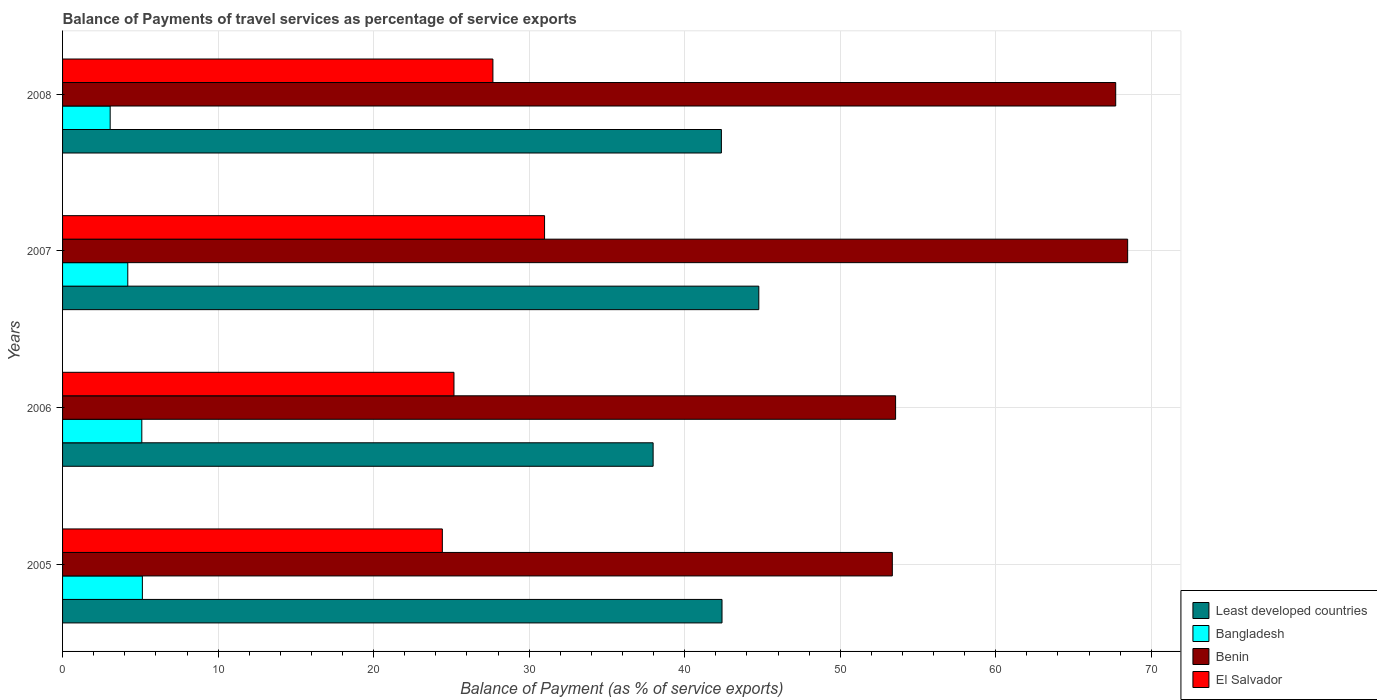How many groups of bars are there?
Ensure brevity in your answer.  4. Are the number of bars on each tick of the Y-axis equal?
Offer a very short reply. Yes. How many bars are there on the 4th tick from the top?
Ensure brevity in your answer.  4. What is the balance of payments of travel services in Benin in 2005?
Provide a succinct answer. 53.35. Across all years, what is the maximum balance of payments of travel services in Bangladesh?
Offer a very short reply. 5.13. Across all years, what is the minimum balance of payments of travel services in Bangladesh?
Offer a very short reply. 3.06. In which year was the balance of payments of travel services in Benin minimum?
Offer a terse response. 2005. What is the total balance of payments of travel services in Bangladesh in the graph?
Give a very brief answer. 17.48. What is the difference between the balance of payments of travel services in Benin in 2006 and that in 2007?
Ensure brevity in your answer.  -14.92. What is the difference between the balance of payments of travel services in Bangladesh in 2005 and the balance of payments of travel services in El Salvador in 2008?
Offer a terse response. -22.54. What is the average balance of payments of travel services in Bangladesh per year?
Ensure brevity in your answer.  4.37. In the year 2007, what is the difference between the balance of payments of travel services in Benin and balance of payments of travel services in Least developed countries?
Offer a terse response. 23.71. What is the ratio of the balance of payments of travel services in Benin in 2005 to that in 2007?
Keep it short and to the point. 0.78. Is the balance of payments of travel services in El Salvador in 2006 less than that in 2008?
Give a very brief answer. Yes. Is the difference between the balance of payments of travel services in Benin in 2005 and 2007 greater than the difference between the balance of payments of travel services in Least developed countries in 2005 and 2007?
Ensure brevity in your answer.  No. What is the difference between the highest and the second highest balance of payments of travel services in Bangladesh?
Your answer should be compact. 0.04. What is the difference between the highest and the lowest balance of payments of travel services in Benin?
Make the answer very short. 15.13. Is it the case that in every year, the sum of the balance of payments of travel services in Benin and balance of payments of travel services in Least developed countries is greater than the sum of balance of payments of travel services in El Salvador and balance of payments of travel services in Bangladesh?
Offer a very short reply. Yes. What does the 3rd bar from the top in 2008 represents?
Your response must be concise. Bangladesh. What does the 4th bar from the bottom in 2008 represents?
Offer a very short reply. El Salvador. Is it the case that in every year, the sum of the balance of payments of travel services in El Salvador and balance of payments of travel services in Bangladesh is greater than the balance of payments of travel services in Least developed countries?
Keep it short and to the point. No. How many bars are there?
Keep it short and to the point. 16. Are all the bars in the graph horizontal?
Your response must be concise. Yes. Are the values on the major ticks of X-axis written in scientific E-notation?
Your answer should be compact. No. Does the graph contain grids?
Keep it short and to the point. Yes. Where does the legend appear in the graph?
Provide a short and direct response. Bottom right. How many legend labels are there?
Ensure brevity in your answer.  4. How are the legend labels stacked?
Give a very brief answer. Vertical. What is the title of the graph?
Provide a succinct answer. Balance of Payments of travel services as percentage of service exports. Does "Bahamas" appear as one of the legend labels in the graph?
Your response must be concise. No. What is the label or title of the X-axis?
Keep it short and to the point. Balance of Payment (as % of service exports). What is the label or title of the Y-axis?
Offer a very short reply. Years. What is the Balance of Payment (as % of service exports) in Least developed countries in 2005?
Offer a very short reply. 42.4. What is the Balance of Payment (as % of service exports) of Bangladesh in 2005?
Make the answer very short. 5.13. What is the Balance of Payment (as % of service exports) of Benin in 2005?
Ensure brevity in your answer.  53.35. What is the Balance of Payment (as % of service exports) of El Salvador in 2005?
Ensure brevity in your answer.  24.42. What is the Balance of Payment (as % of service exports) of Least developed countries in 2006?
Give a very brief answer. 37.97. What is the Balance of Payment (as % of service exports) in Bangladesh in 2006?
Your response must be concise. 5.1. What is the Balance of Payment (as % of service exports) in Benin in 2006?
Offer a terse response. 53.56. What is the Balance of Payment (as % of service exports) of El Salvador in 2006?
Offer a terse response. 25.17. What is the Balance of Payment (as % of service exports) of Least developed countries in 2007?
Give a very brief answer. 44.76. What is the Balance of Payment (as % of service exports) in Bangladesh in 2007?
Offer a terse response. 4.19. What is the Balance of Payment (as % of service exports) of Benin in 2007?
Offer a very short reply. 68.48. What is the Balance of Payment (as % of service exports) of El Salvador in 2007?
Give a very brief answer. 30.99. What is the Balance of Payment (as % of service exports) in Least developed countries in 2008?
Provide a short and direct response. 42.36. What is the Balance of Payment (as % of service exports) in Bangladesh in 2008?
Your answer should be compact. 3.06. What is the Balance of Payment (as % of service exports) in Benin in 2008?
Keep it short and to the point. 67.71. What is the Balance of Payment (as % of service exports) in El Salvador in 2008?
Your answer should be very brief. 27.67. Across all years, what is the maximum Balance of Payment (as % of service exports) of Least developed countries?
Your answer should be very brief. 44.76. Across all years, what is the maximum Balance of Payment (as % of service exports) in Bangladesh?
Keep it short and to the point. 5.13. Across all years, what is the maximum Balance of Payment (as % of service exports) in Benin?
Provide a short and direct response. 68.48. Across all years, what is the maximum Balance of Payment (as % of service exports) of El Salvador?
Provide a succinct answer. 30.99. Across all years, what is the minimum Balance of Payment (as % of service exports) of Least developed countries?
Your response must be concise. 37.97. Across all years, what is the minimum Balance of Payment (as % of service exports) in Bangladesh?
Your answer should be compact. 3.06. Across all years, what is the minimum Balance of Payment (as % of service exports) in Benin?
Your answer should be compact. 53.35. Across all years, what is the minimum Balance of Payment (as % of service exports) of El Salvador?
Make the answer very short. 24.42. What is the total Balance of Payment (as % of service exports) of Least developed countries in the graph?
Give a very brief answer. 167.49. What is the total Balance of Payment (as % of service exports) of Bangladesh in the graph?
Give a very brief answer. 17.48. What is the total Balance of Payment (as % of service exports) of Benin in the graph?
Ensure brevity in your answer.  243.1. What is the total Balance of Payment (as % of service exports) in El Salvador in the graph?
Make the answer very short. 108.24. What is the difference between the Balance of Payment (as % of service exports) in Least developed countries in 2005 and that in 2006?
Your answer should be compact. 4.43. What is the difference between the Balance of Payment (as % of service exports) in Bangladesh in 2005 and that in 2006?
Your response must be concise. 0.04. What is the difference between the Balance of Payment (as % of service exports) of Benin in 2005 and that in 2006?
Offer a terse response. -0.21. What is the difference between the Balance of Payment (as % of service exports) in El Salvador in 2005 and that in 2006?
Provide a short and direct response. -0.75. What is the difference between the Balance of Payment (as % of service exports) of Least developed countries in 2005 and that in 2007?
Ensure brevity in your answer.  -2.37. What is the difference between the Balance of Payment (as % of service exports) of Bangladesh in 2005 and that in 2007?
Provide a succinct answer. 0.94. What is the difference between the Balance of Payment (as % of service exports) in Benin in 2005 and that in 2007?
Provide a short and direct response. -15.13. What is the difference between the Balance of Payment (as % of service exports) of El Salvador in 2005 and that in 2007?
Offer a terse response. -6.57. What is the difference between the Balance of Payment (as % of service exports) of Least developed countries in 2005 and that in 2008?
Your answer should be very brief. 0.04. What is the difference between the Balance of Payment (as % of service exports) in Bangladesh in 2005 and that in 2008?
Make the answer very short. 2.07. What is the difference between the Balance of Payment (as % of service exports) of Benin in 2005 and that in 2008?
Make the answer very short. -14.36. What is the difference between the Balance of Payment (as % of service exports) in El Salvador in 2005 and that in 2008?
Your response must be concise. -3.25. What is the difference between the Balance of Payment (as % of service exports) of Least developed countries in 2006 and that in 2007?
Your answer should be very brief. -6.79. What is the difference between the Balance of Payment (as % of service exports) in Bangladesh in 2006 and that in 2007?
Your answer should be very brief. 0.9. What is the difference between the Balance of Payment (as % of service exports) of Benin in 2006 and that in 2007?
Your answer should be very brief. -14.92. What is the difference between the Balance of Payment (as % of service exports) of El Salvador in 2006 and that in 2007?
Your answer should be very brief. -5.82. What is the difference between the Balance of Payment (as % of service exports) in Least developed countries in 2006 and that in 2008?
Provide a short and direct response. -4.39. What is the difference between the Balance of Payment (as % of service exports) of Bangladesh in 2006 and that in 2008?
Your answer should be very brief. 2.04. What is the difference between the Balance of Payment (as % of service exports) of Benin in 2006 and that in 2008?
Provide a short and direct response. -14.15. What is the difference between the Balance of Payment (as % of service exports) in El Salvador in 2006 and that in 2008?
Make the answer very short. -2.5. What is the difference between the Balance of Payment (as % of service exports) of Least developed countries in 2007 and that in 2008?
Your answer should be very brief. 2.41. What is the difference between the Balance of Payment (as % of service exports) of Bangladesh in 2007 and that in 2008?
Give a very brief answer. 1.13. What is the difference between the Balance of Payment (as % of service exports) in Benin in 2007 and that in 2008?
Keep it short and to the point. 0.77. What is the difference between the Balance of Payment (as % of service exports) in El Salvador in 2007 and that in 2008?
Your response must be concise. 3.32. What is the difference between the Balance of Payment (as % of service exports) in Least developed countries in 2005 and the Balance of Payment (as % of service exports) in Bangladesh in 2006?
Provide a short and direct response. 37.3. What is the difference between the Balance of Payment (as % of service exports) of Least developed countries in 2005 and the Balance of Payment (as % of service exports) of Benin in 2006?
Keep it short and to the point. -11.16. What is the difference between the Balance of Payment (as % of service exports) of Least developed countries in 2005 and the Balance of Payment (as % of service exports) of El Salvador in 2006?
Provide a succinct answer. 17.23. What is the difference between the Balance of Payment (as % of service exports) in Bangladesh in 2005 and the Balance of Payment (as % of service exports) in Benin in 2006?
Provide a short and direct response. -48.43. What is the difference between the Balance of Payment (as % of service exports) of Bangladesh in 2005 and the Balance of Payment (as % of service exports) of El Salvador in 2006?
Keep it short and to the point. -20.03. What is the difference between the Balance of Payment (as % of service exports) in Benin in 2005 and the Balance of Payment (as % of service exports) in El Salvador in 2006?
Offer a terse response. 28.18. What is the difference between the Balance of Payment (as % of service exports) of Least developed countries in 2005 and the Balance of Payment (as % of service exports) of Bangladesh in 2007?
Provide a succinct answer. 38.21. What is the difference between the Balance of Payment (as % of service exports) in Least developed countries in 2005 and the Balance of Payment (as % of service exports) in Benin in 2007?
Make the answer very short. -26.08. What is the difference between the Balance of Payment (as % of service exports) in Least developed countries in 2005 and the Balance of Payment (as % of service exports) in El Salvador in 2007?
Make the answer very short. 11.41. What is the difference between the Balance of Payment (as % of service exports) of Bangladesh in 2005 and the Balance of Payment (as % of service exports) of Benin in 2007?
Make the answer very short. -63.35. What is the difference between the Balance of Payment (as % of service exports) in Bangladesh in 2005 and the Balance of Payment (as % of service exports) in El Salvador in 2007?
Provide a short and direct response. -25.86. What is the difference between the Balance of Payment (as % of service exports) of Benin in 2005 and the Balance of Payment (as % of service exports) of El Salvador in 2007?
Your answer should be very brief. 22.36. What is the difference between the Balance of Payment (as % of service exports) of Least developed countries in 2005 and the Balance of Payment (as % of service exports) of Bangladesh in 2008?
Make the answer very short. 39.34. What is the difference between the Balance of Payment (as % of service exports) of Least developed countries in 2005 and the Balance of Payment (as % of service exports) of Benin in 2008?
Ensure brevity in your answer.  -25.31. What is the difference between the Balance of Payment (as % of service exports) in Least developed countries in 2005 and the Balance of Payment (as % of service exports) in El Salvador in 2008?
Give a very brief answer. 14.73. What is the difference between the Balance of Payment (as % of service exports) of Bangladesh in 2005 and the Balance of Payment (as % of service exports) of Benin in 2008?
Your answer should be compact. -62.58. What is the difference between the Balance of Payment (as % of service exports) in Bangladesh in 2005 and the Balance of Payment (as % of service exports) in El Salvador in 2008?
Keep it short and to the point. -22.54. What is the difference between the Balance of Payment (as % of service exports) in Benin in 2005 and the Balance of Payment (as % of service exports) in El Salvador in 2008?
Provide a succinct answer. 25.68. What is the difference between the Balance of Payment (as % of service exports) in Least developed countries in 2006 and the Balance of Payment (as % of service exports) in Bangladesh in 2007?
Give a very brief answer. 33.78. What is the difference between the Balance of Payment (as % of service exports) of Least developed countries in 2006 and the Balance of Payment (as % of service exports) of Benin in 2007?
Offer a very short reply. -30.51. What is the difference between the Balance of Payment (as % of service exports) in Least developed countries in 2006 and the Balance of Payment (as % of service exports) in El Salvador in 2007?
Your answer should be very brief. 6.98. What is the difference between the Balance of Payment (as % of service exports) in Bangladesh in 2006 and the Balance of Payment (as % of service exports) in Benin in 2007?
Make the answer very short. -63.38. What is the difference between the Balance of Payment (as % of service exports) of Bangladesh in 2006 and the Balance of Payment (as % of service exports) of El Salvador in 2007?
Your response must be concise. -25.89. What is the difference between the Balance of Payment (as % of service exports) of Benin in 2006 and the Balance of Payment (as % of service exports) of El Salvador in 2007?
Make the answer very short. 22.57. What is the difference between the Balance of Payment (as % of service exports) of Least developed countries in 2006 and the Balance of Payment (as % of service exports) of Bangladesh in 2008?
Give a very brief answer. 34.91. What is the difference between the Balance of Payment (as % of service exports) in Least developed countries in 2006 and the Balance of Payment (as % of service exports) in Benin in 2008?
Provide a succinct answer. -29.74. What is the difference between the Balance of Payment (as % of service exports) in Least developed countries in 2006 and the Balance of Payment (as % of service exports) in El Salvador in 2008?
Provide a short and direct response. 10.3. What is the difference between the Balance of Payment (as % of service exports) of Bangladesh in 2006 and the Balance of Payment (as % of service exports) of Benin in 2008?
Provide a short and direct response. -62.62. What is the difference between the Balance of Payment (as % of service exports) of Bangladesh in 2006 and the Balance of Payment (as % of service exports) of El Salvador in 2008?
Make the answer very short. -22.57. What is the difference between the Balance of Payment (as % of service exports) in Benin in 2006 and the Balance of Payment (as % of service exports) in El Salvador in 2008?
Provide a succinct answer. 25.89. What is the difference between the Balance of Payment (as % of service exports) in Least developed countries in 2007 and the Balance of Payment (as % of service exports) in Bangladesh in 2008?
Give a very brief answer. 41.7. What is the difference between the Balance of Payment (as % of service exports) of Least developed countries in 2007 and the Balance of Payment (as % of service exports) of Benin in 2008?
Provide a short and direct response. -22.95. What is the difference between the Balance of Payment (as % of service exports) of Least developed countries in 2007 and the Balance of Payment (as % of service exports) of El Salvador in 2008?
Give a very brief answer. 17.1. What is the difference between the Balance of Payment (as % of service exports) of Bangladesh in 2007 and the Balance of Payment (as % of service exports) of Benin in 2008?
Your answer should be compact. -63.52. What is the difference between the Balance of Payment (as % of service exports) in Bangladesh in 2007 and the Balance of Payment (as % of service exports) in El Salvador in 2008?
Ensure brevity in your answer.  -23.48. What is the difference between the Balance of Payment (as % of service exports) in Benin in 2007 and the Balance of Payment (as % of service exports) in El Salvador in 2008?
Your answer should be compact. 40.81. What is the average Balance of Payment (as % of service exports) in Least developed countries per year?
Give a very brief answer. 41.87. What is the average Balance of Payment (as % of service exports) of Bangladesh per year?
Your answer should be very brief. 4.37. What is the average Balance of Payment (as % of service exports) of Benin per year?
Your response must be concise. 60.77. What is the average Balance of Payment (as % of service exports) of El Salvador per year?
Provide a succinct answer. 27.06. In the year 2005, what is the difference between the Balance of Payment (as % of service exports) of Least developed countries and Balance of Payment (as % of service exports) of Bangladesh?
Provide a short and direct response. 37.27. In the year 2005, what is the difference between the Balance of Payment (as % of service exports) of Least developed countries and Balance of Payment (as % of service exports) of Benin?
Ensure brevity in your answer.  -10.95. In the year 2005, what is the difference between the Balance of Payment (as % of service exports) in Least developed countries and Balance of Payment (as % of service exports) in El Salvador?
Offer a terse response. 17.98. In the year 2005, what is the difference between the Balance of Payment (as % of service exports) in Bangladesh and Balance of Payment (as % of service exports) in Benin?
Offer a terse response. -48.22. In the year 2005, what is the difference between the Balance of Payment (as % of service exports) in Bangladesh and Balance of Payment (as % of service exports) in El Salvador?
Offer a terse response. -19.29. In the year 2005, what is the difference between the Balance of Payment (as % of service exports) of Benin and Balance of Payment (as % of service exports) of El Salvador?
Ensure brevity in your answer.  28.93. In the year 2006, what is the difference between the Balance of Payment (as % of service exports) in Least developed countries and Balance of Payment (as % of service exports) in Bangladesh?
Provide a succinct answer. 32.87. In the year 2006, what is the difference between the Balance of Payment (as % of service exports) in Least developed countries and Balance of Payment (as % of service exports) in Benin?
Your response must be concise. -15.59. In the year 2006, what is the difference between the Balance of Payment (as % of service exports) in Least developed countries and Balance of Payment (as % of service exports) in El Salvador?
Your response must be concise. 12.8. In the year 2006, what is the difference between the Balance of Payment (as % of service exports) of Bangladesh and Balance of Payment (as % of service exports) of Benin?
Provide a succinct answer. -48.46. In the year 2006, what is the difference between the Balance of Payment (as % of service exports) of Bangladesh and Balance of Payment (as % of service exports) of El Salvador?
Make the answer very short. -20.07. In the year 2006, what is the difference between the Balance of Payment (as % of service exports) of Benin and Balance of Payment (as % of service exports) of El Salvador?
Keep it short and to the point. 28.39. In the year 2007, what is the difference between the Balance of Payment (as % of service exports) of Least developed countries and Balance of Payment (as % of service exports) of Bangladesh?
Make the answer very short. 40.57. In the year 2007, what is the difference between the Balance of Payment (as % of service exports) of Least developed countries and Balance of Payment (as % of service exports) of Benin?
Keep it short and to the point. -23.71. In the year 2007, what is the difference between the Balance of Payment (as % of service exports) in Least developed countries and Balance of Payment (as % of service exports) in El Salvador?
Ensure brevity in your answer.  13.77. In the year 2007, what is the difference between the Balance of Payment (as % of service exports) of Bangladesh and Balance of Payment (as % of service exports) of Benin?
Provide a short and direct response. -64.29. In the year 2007, what is the difference between the Balance of Payment (as % of service exports) of Bangladesh and Balance of Payment (as % of service exports) of El Salvador?
Offer a very short reply. -26.8. In the year 2007, what is the difference between the Balance of Payment (as % of service exports) of Benin and Balance of Payment (as % of service exports) of El Salvador?
Give a very brief answer. 37.49. In the year 2008, what is the difference between the Balance of Payment (as % of service exports) in Least developed countries and Balance of Payment (as % of service exports) in Bangladesh?
Provide a succinct answer. 39.3. In the year 2008, what is the difference between the Balance of Payment (as % of service exports) of Least developed countries and Balance of Payment (as % of service exports) of Benin?
Offer a very short reply. -25.35. In the year 2008, what is the difference between the Balance of Payment (as % of service exports) of Least developed countries and Balance of Payment (as % of service exports) of El Salvador?
Your response must be concise. 14.69. In the year 2008, what is the difference between the Balance of Payment (as % of service exports) in Bangladesh and Balance of Payment (as % of service exports) in Benin?
Your answer should be very brief. -64.65. In the year 2008, what is the difference between the Balance of Payment (as % of service exports) in Bangladesh and Balance of Payment (as % of service exports) in El Salvador?
Offer a very short reply. -24.61. In the year 2008, what is the difference between the Balance of Payment (as % of service exports) in Benin and Balance of Payment (as % of service exports) in El Salvador?
Make the answer very short. 40.04. What is the ratio of the Balance of Payment (as % of service exports) of Least developed countries in 2005 to that in 2006?
Offer a very short reply. 1.12. What is the ratio of the Balance of Payment (as % of service exports) of Benin in 2005 to that in 2006?
Offer a very short reply. 1. What is the ratio of the Balance of Payment (as % of service exports) of El Salvador in 2005 to that in 2006?
Your response must be concise. 0.97. What is the ratio of the Balance of Payment (as % of service exports) of Least developed countries in 2005 to that in 2007?
Your response must be concise. 0.95. What is the ratio of the Balance of Payment (as % of service exports) of Bangladesh in 2005 to that in 2007?
Your response must be concise. 1.22. What is the ratio of the Balance of Payment (as % of service exports) of Benin in 2005 to that in 2007?
Provide a short and direct response. 0.78. What is the ratio of the Balance of Payment (as % of service exports) of El Salvador in 2005 to that in 2007?
Make the answer very short. 0.79. What is the ratio of the Balance of Payment (as % of service exports) of Bangladesh in 2005 to that in 2008?
Provide a succinct answer. 1.68. What is the ratio of the Balance of Payment (as % of service exports) in Benin in 2005 to that in 2008?
Your response must be concise. 0.79. What is the ratio of the Balance of Payment (as % of service exports) in El Salvador in 2005 to that in 2008?
Offer a terse response. 0.88. What is the ratio of the Balance of Payment (as % of service exports) in Least developed countries in 2006 to that in 2007?
Provide a short and direct response. 0.85. What is the ratio of the Balance of Payment (as % of service exports) in Bangladesh in 2006 to that in 2007?
Give a very brief answer. 1.22. What is the ratio of the Balance of Payment (as % of service exports) in Benin in 2006 to that in 2007?
Offer a terse response. 0.78. What is the ratio of the Balance of Payment (as % of service exports) in El Salvador in 2006 to that in 2007?
Your answer should be very brief. 0.81. What is the ratio of the Balance of Payment (as % of service exports) in Least developed countries in 2006 to that in 2008?
Keep it short and to the point. 0.9. What is the ratio of the Balance of Payment (as % of service exports) in Bangladesh in 2006 to that in 2008?
Your response must be concise. 1.66. What is the ratio of the Balance of Payment (as % of service exports) in Benin in 2006 to that in 2008?
Your response must be concise. 0.79. What is the ratio of the Balance of Payment (as % of service exports) in El Salvador in 2006 to that in 2008?
Provide a short and direct response. 0.91. What is the ratio of the Balance of Payment (as % of service exports) of Least developed countries in 2007 to that in 2008?
Offer a terse response. 1.06. What is the ratio of the Balance of Payment (as % of service exports) in Bangladesh in 2007 to that in 2008?
Offer a very short reply. 1.37. What is the ratio of the Balance of Payment (as % of service exports) of Benin in 2007 to that in 2008?
Offer a very short reply. 1.01. What is the ratio of the Balance of Payment (as % of service exports) in El Salvador in 2007 to that in 2008?
Give a very brief answer. 1.12. What is the difference between the highest and the second highest Balance of Payment (as % of service exports) of Least developed countries?
Ensure brevity in your answer.  2.37. What is the difference between the highest and the second highest Balance of Payment (as % of service exports) in Bangladesh?
Ensure brevity in your answer.  0.04. What is the difference between the highest and the second highest Balance of Payment (as % of service exports) in Benin?
Ensure brevity in your answer.  0.77. What is the difference between the highest and the second highest Balance of Payment (as % of service exports) in El Salvador?
Give a very brief answer. 3.32. What is the difference between the highest and the lowest Balance of Payment (as % of service exports) in Least developed countries?
Ensure brevity in your answer.  6.79. What is the difference between the highest and the lowest Balance of Payment (as % of service exports) in Bangladesh?
Your response must be concise. 2.07. What is the difference between the highest and the lowest Balance of Payment (as % of service exports) in Benin?
Offer a terse response. 15.13. What is the difference between the highest and the lowest Balance of Payment (as % of service exports) of El Salvador?
Make the answer very short. 6.57. 